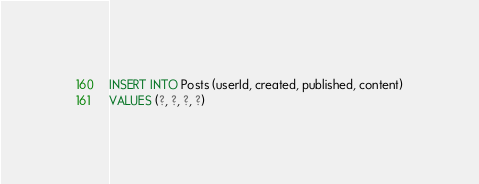Convert code to text. <code><loc_0><loc_0><loc_500><loc_500><_SQL_>INSERT INTO Posts (userId, created, published, content)
VALUES (?, ?, ?, ?)</code> 